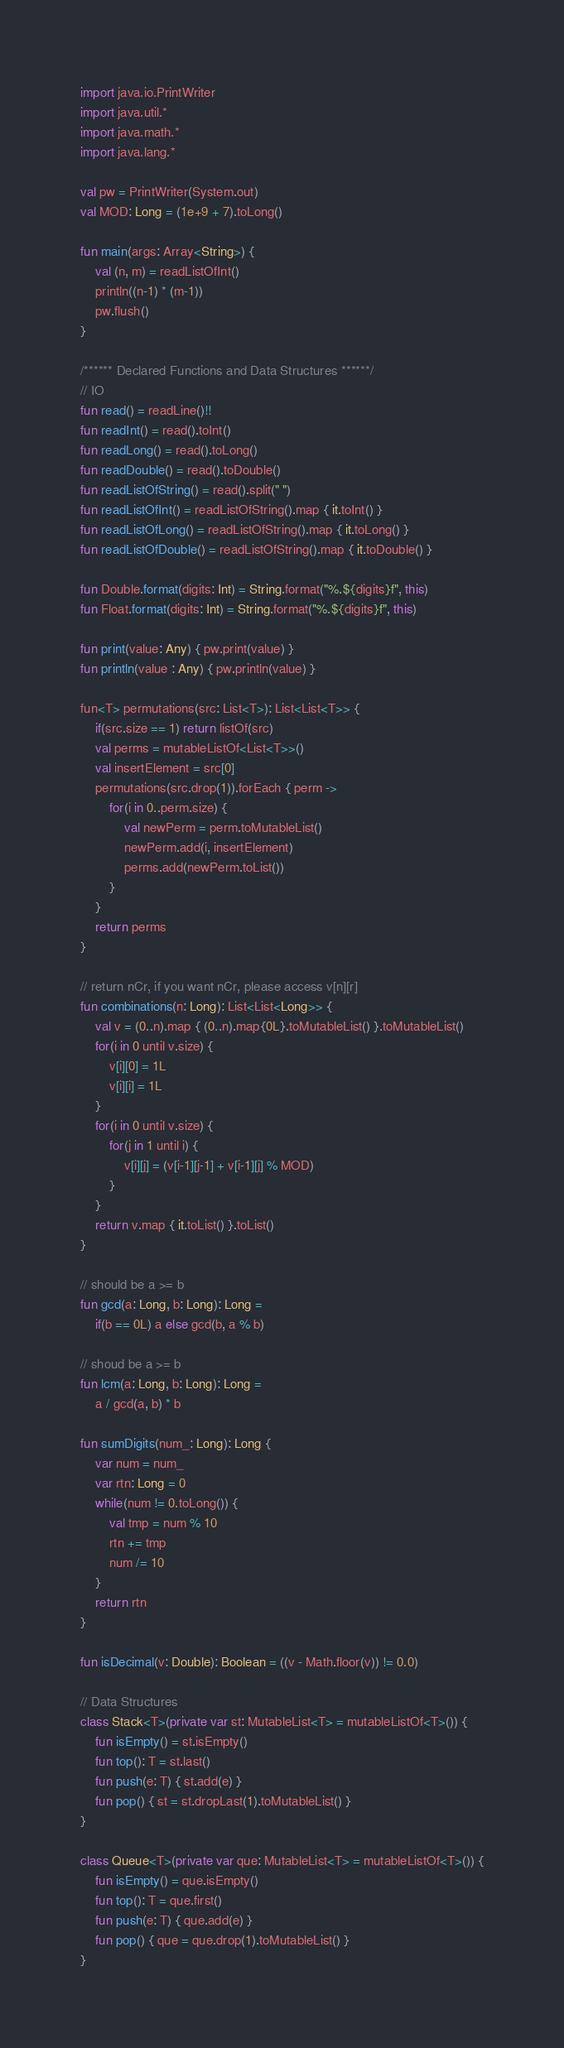<code> <loc_0><loc_0><loc_500><loc_500><_Kotlin_>import java.io.PrintWriter
import java.util.*
import java.math.*
import java.lang.*

val pw = PrintWriter(System.out)
val MOD: Long = (1e+9 + 7).toLong()

fun main(args: Array<String>) {
    val (n, m) = readListOfInt() 
    println((n-1) * (m-1))
    pw.flush()
}

/****** Declared Functions and Data Structures ******/
// IO
fun read() = readLine()!!
fun readInt() = read().toInt()
fun readLong() = read().toLong()
fun readDouble() = read().toDouble()
fun readListOfString() = read().split(" ")
fun readListOfInt() = readListOfString().map { it.toInt() }
fun readListOfLong() = readListOfString().map { it.toLong() }
fun readListOfDouble() = readListOfString().map { it.toDouble() }

fun Double.format(digits: Int) = String.format("%.${digits}f", this)
fun Float.format(digits: Int) = String.format("%.${digits}f", this)

fun print(value: Any) { pw.print(value) }
fun println(value : Any) { pw.println(value) }

fun<T> permutations(src: List<T>): List<List<T>> {
    if(src.size == 1) return listOf(src)
    val perms = mutableListOf<List<T>>()
    val insertElement = src[0]
    permutations(src.drop(1)).forEach { perm ->
        for(i in 0..perm.size) {
            val newPerm = perm.toMutableList()
            newPerm.add(i, insertElement)
            perms.add(newPerm.toList())
        }
    }
    return perms
}

// return nCr, if you want nCr, please access v[n][r]
fun combinations(n: Long): List<List<Long>> {
    val v = (0..n).map { (0..n).map{0L}.toMutableList() }.toMutableList()
    for(i in 0 until v.size) {
        v[i][0] = 1L
        v[i][i] = 1L
    }
    for(i in 0 until v.size) {
        for(j in 1 until i) {
            v[i][j] = (v[i-1][j-1] + v[i-1][j] % MOD)
        }
    }
    return v.map { it.toList() }.toList()
}

// should be a >= b
fun gcd(a: Long, b: Long): Long = 
    if(b == 0L) a else gcd(b, a % b)

// shoud be a >= b
fun lcm(a: Long, b: Long): Long = 
    a / gcd(a, b) * b

fun sumDigits(num_: Long): Long {
    var num = num_
    var rtn: Long = 0
    while(num != 0.toLong()) {
        val tmp = num % 10
        rtn += tmp
        num /= 10
    }
    return rtn
}

fun isDecimal(v: Double): Boolean = ((v - Math.floor(v)) != 0.0)

// Data Structures
class Stack<T>(private var st: MutableList<T> = mutableListOf<T>()) {
    fun isEmpty() = st.isEmpty()
    fun top(): T = st.last()
    fun push(e: T) { st.add(e) }
    fun pop() { st = st.dropLast(1).toMutableList() }
}

class Queue<T>(private var que: MutableList<T> = mutableListOf<T>()) {
    fun isEmpty() = que.isEmpty()
    fun top(): T = que.first()
    fun push(e: T) { que.add(e) }
    fun pop() { que = que.drop(1).toMutableList() }
}
</code> 